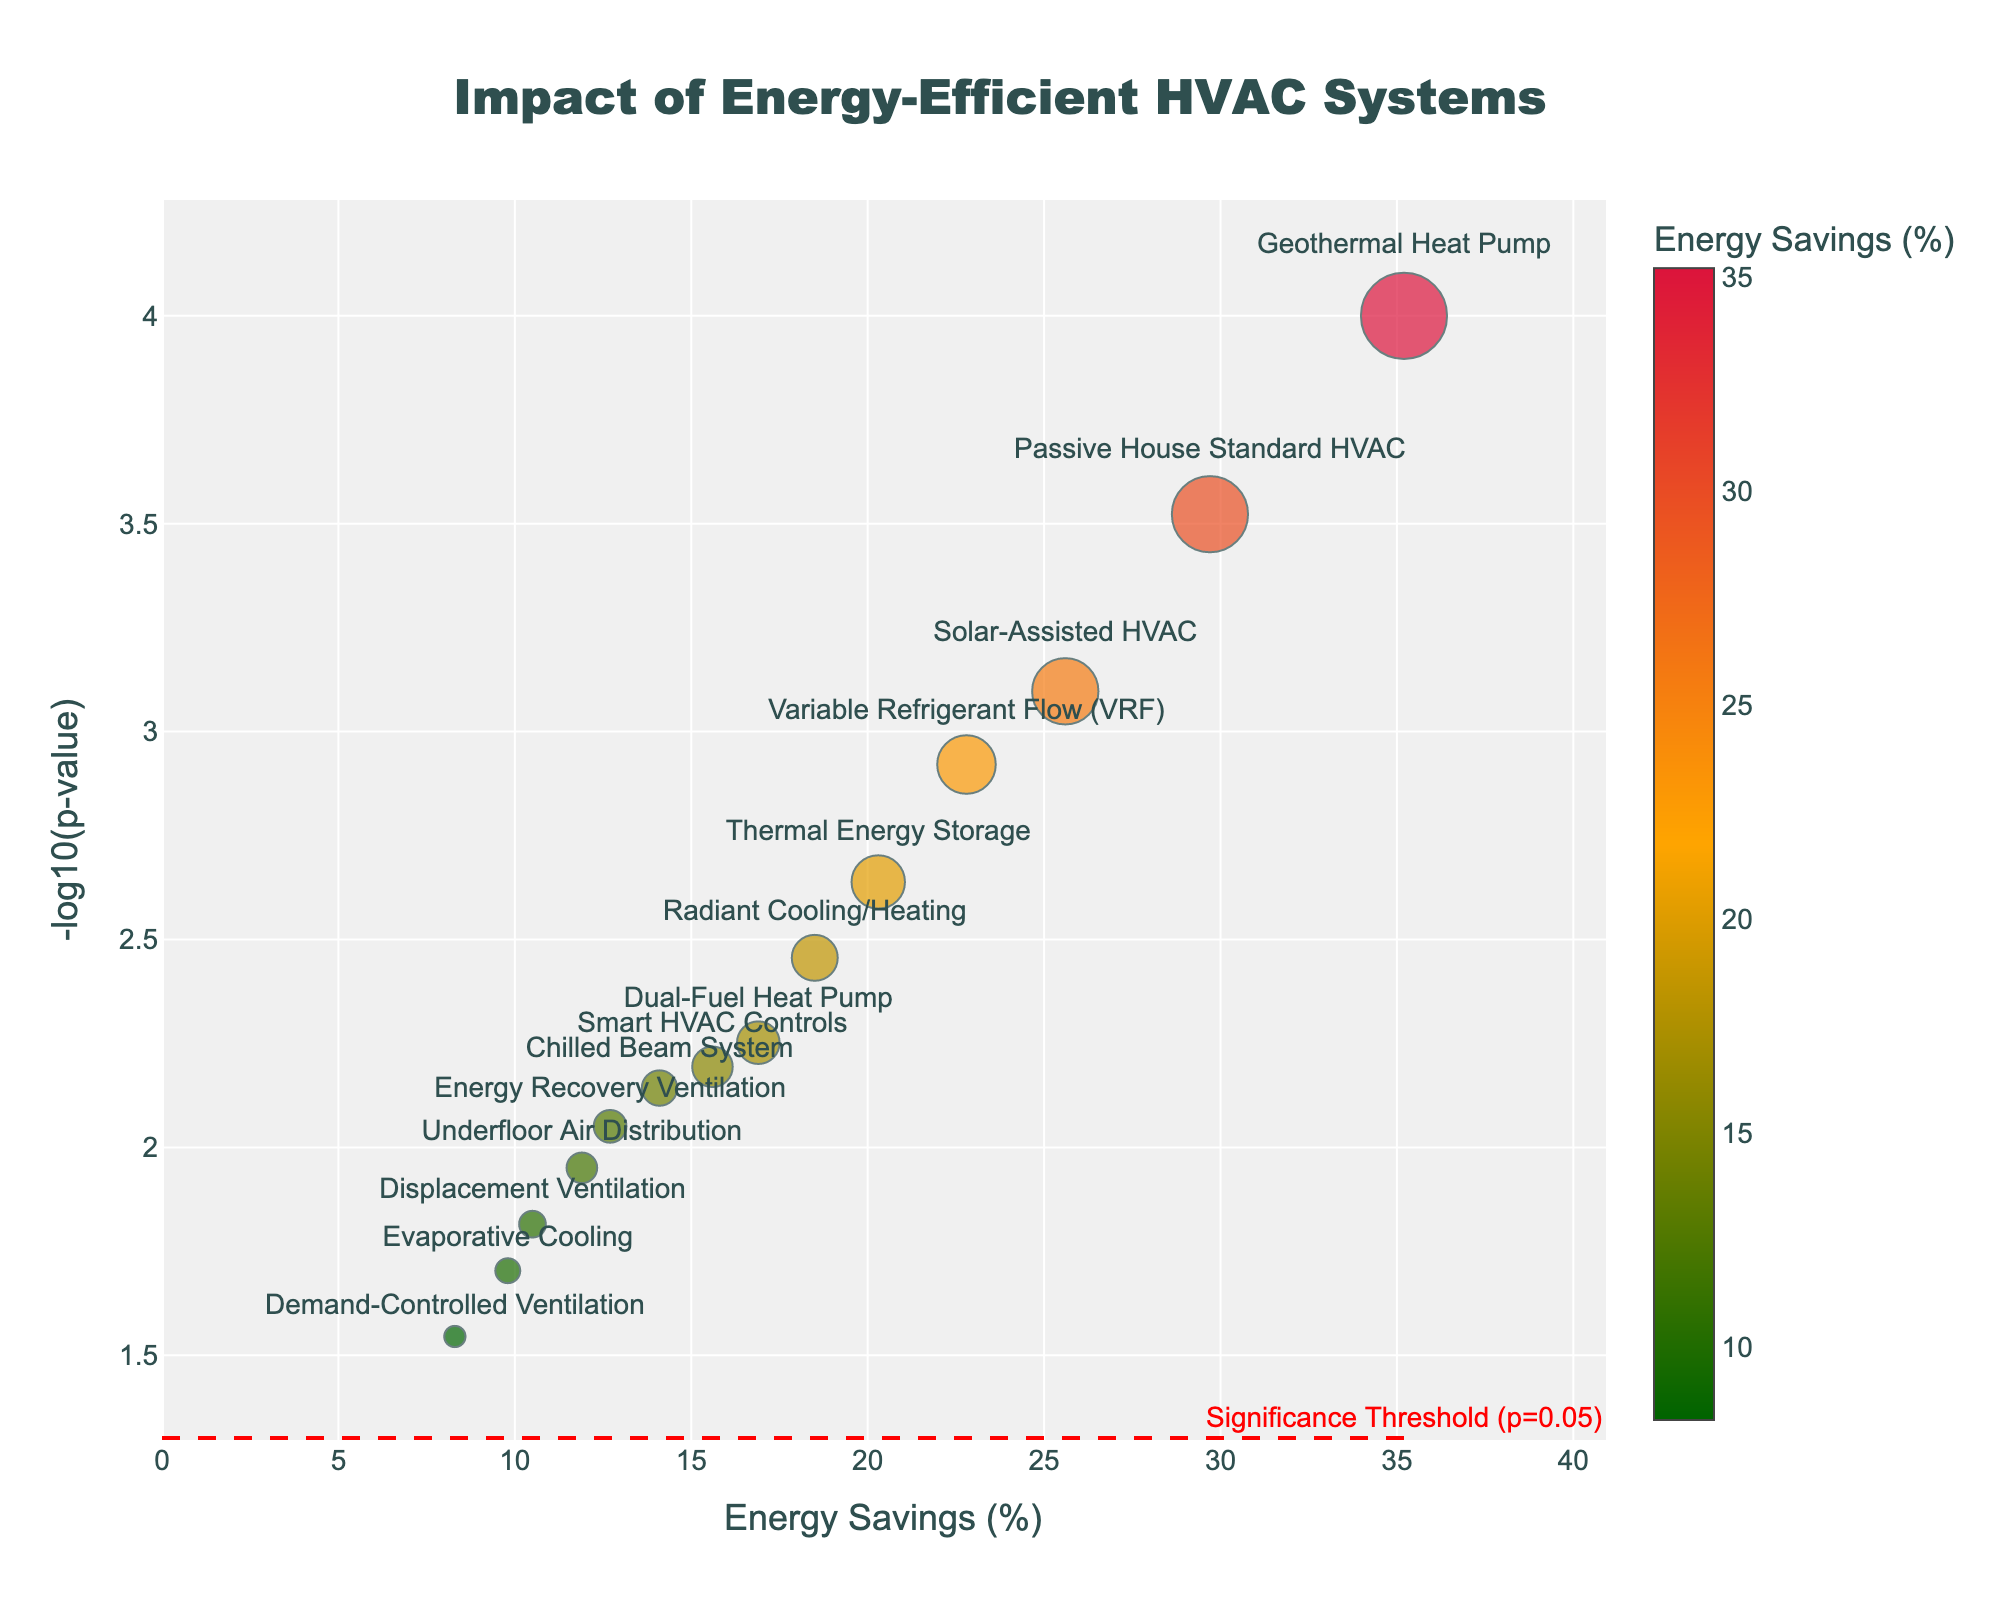Which HVAC system shows the highest energy savings? By looking at the x-axis, which represents energy savings percentage, identify the data point furthest to the right.
Answer: Geothermal Heat Pump What does a red horizontal line at a certain y-value indicate? By examining the red horizontal line in the figure, it is labeled with 'Significance Threshold (p=0.05)', indicating this line represents the statistical significance threshold for the p-value.
Answer: Significance Threshold (p=0.05) Which system has the highest -log10(p-value)? By locating the highest y-value on the plot, the data point that reaches the highest -log10(p-value) represents the system with the most statistically significant result.
Answer: Geothermal Heat Pump How many systems have a p-value below 0.05? Identify all the dots above the red threshold line. Count each of these dots.
Answer: 11 systems What is the cost savings percentage of the system with the second highest energy savings? First, identify the system with the second highest energy savings by looking at the x-axis. Then, refer to the size of the corresponding data point for its cost savings percentage.
Answer: Passive House Standard HVAC Which systems have both energy savings above 20% and significant p-value (below 0.05)? Look for systems with energy savings values greater than 20 on the x-axis and that are above the red threshold line for a significant p-value.
Answer: Geothermal Heat Pump, Variable Refrigerant Flow (VRF), Passive House Standard HVAC, Solar-Assisted HVAC What are the energy savings and cost savings percentages for Dual-Fuel Heat Pump? Locate the data point labeled 'Dual-Fuel Heat Pump'. Read the x-axis value for energy savings and the corresponding point size for cost savings.
Answer: Energy Savings: 16.9%, Cost Savings: 14.2% Which has a higher cost savings percentage: Radiant Cooling/Heating or Displacement Ventilation? Compare the sizes of the points labeled 'Radiant Cooling/Heating' and 'Displacement Ventilation'. The larger point represents higher cost savings.
Answer: Radiant Cooling/Heating What can be inferred about systems below the significance threshold line (p=0.05)? Systems below the red threshold line have p-values greater than 0.05, indicating they aren't statistically significant.
Answer: Not statistically significant Does Evaporative Cooling have significant or not significant results based on p-value? Locate 'Evaporative Cooling'. Check if it's below the red threshold line which represents a p-value of 0.05.
Answer: Not significant 